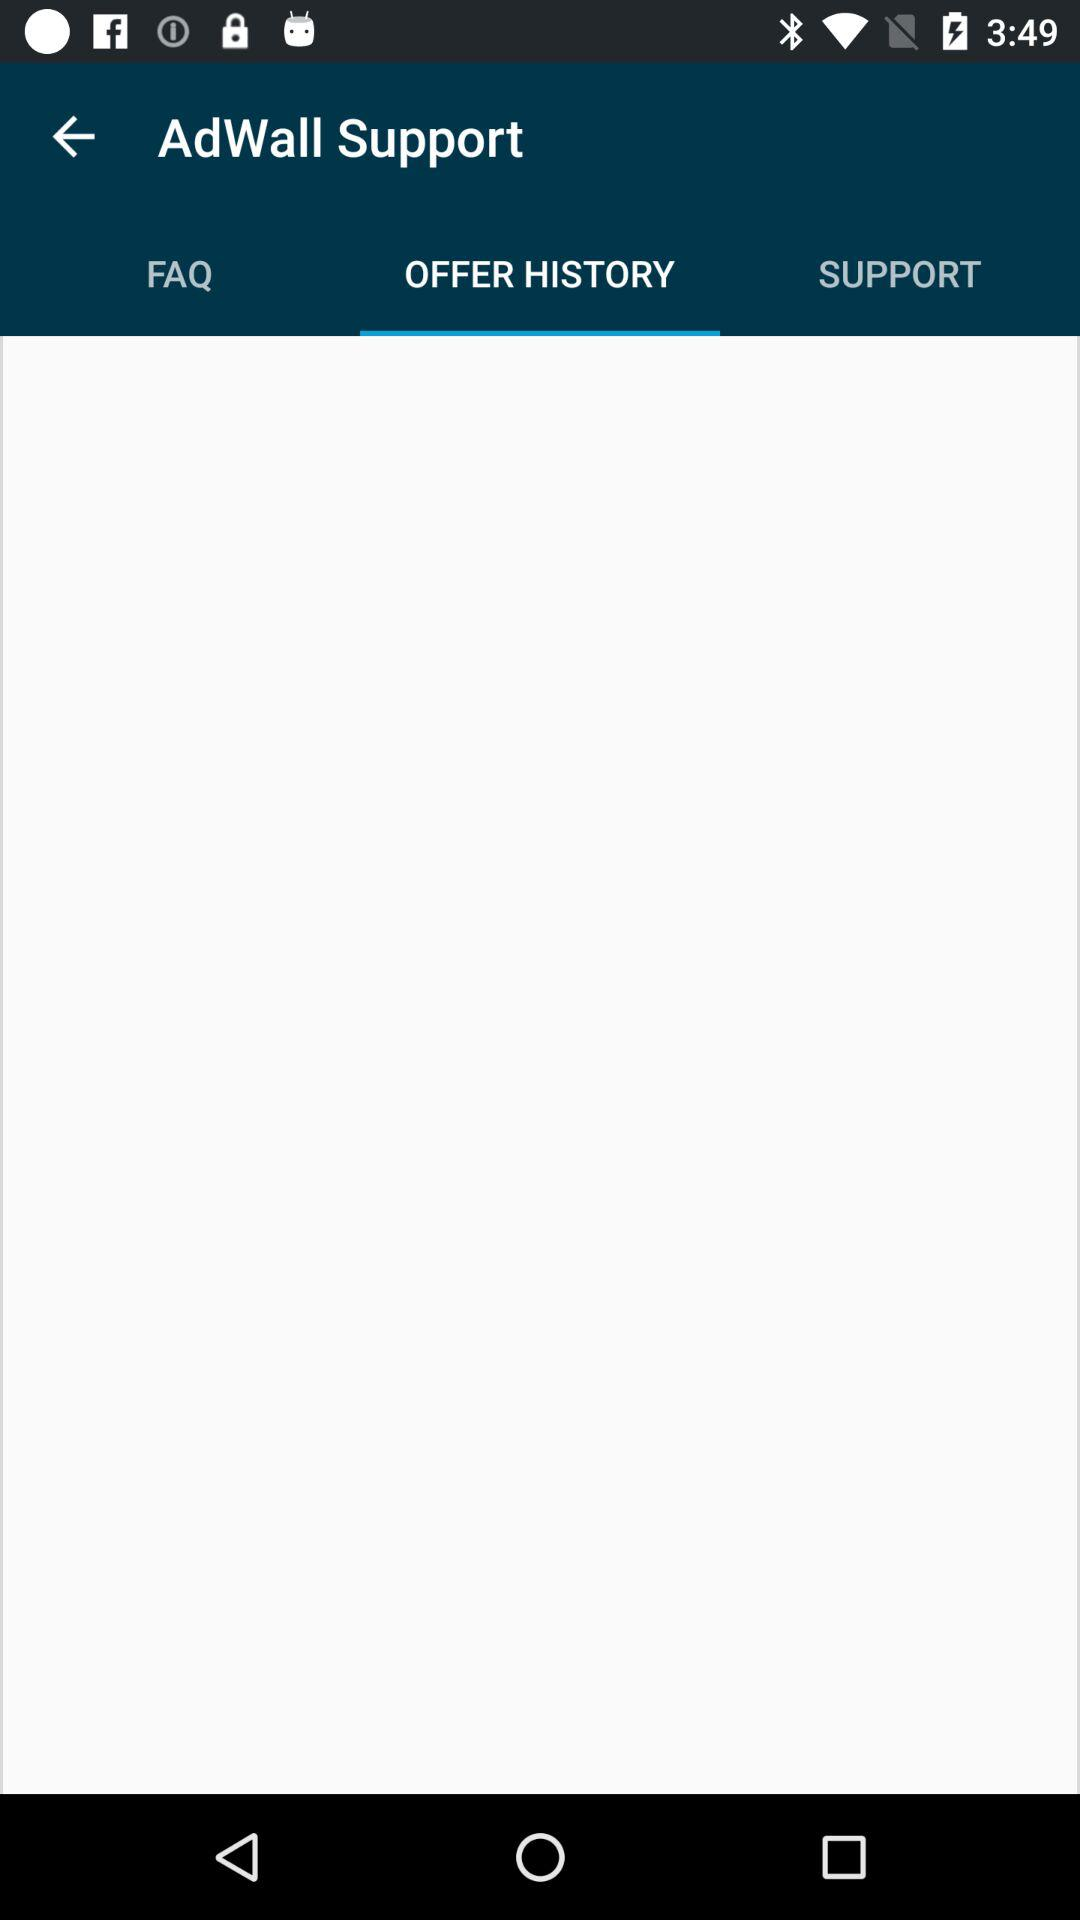Which tab is selected? The selected tab is "OFFER HISTORY". 